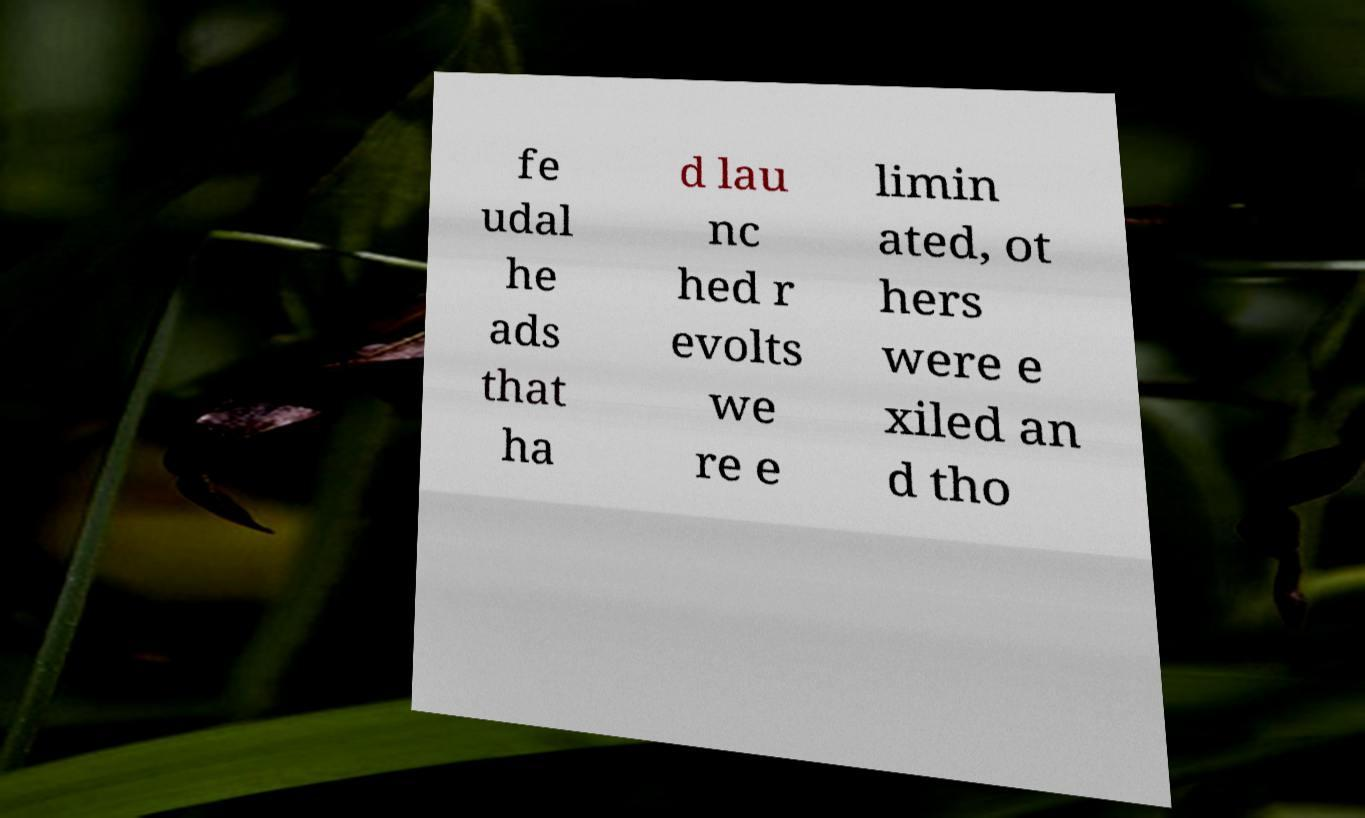Please read and relay the text visible in this image. What does it say? fe udal he ads that ha d lau nc hed r evolts we re e limin ated, ot hers were e xiled an d tho 